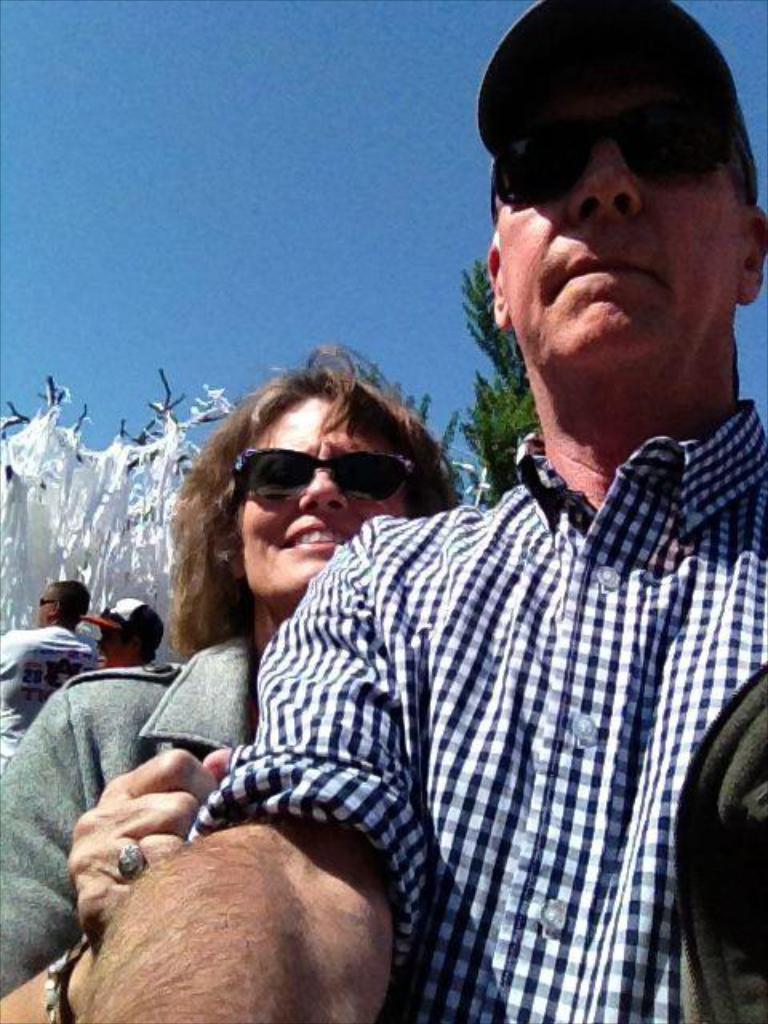Who is present in the image? There is a woman and three men in the image. What can be seen in the background of the image? There are trees and white color objects in the background of the image. What is visible at the top of the image? The sky is visible at the top of the image. What type of kite is being flown by the woman in the image? There is no kite present in the image; it only features a woman and three men. What type of trade is being conducted by the men in the image? There is no indication of any trade being conducted in the image; it only shows a woman and three men. 